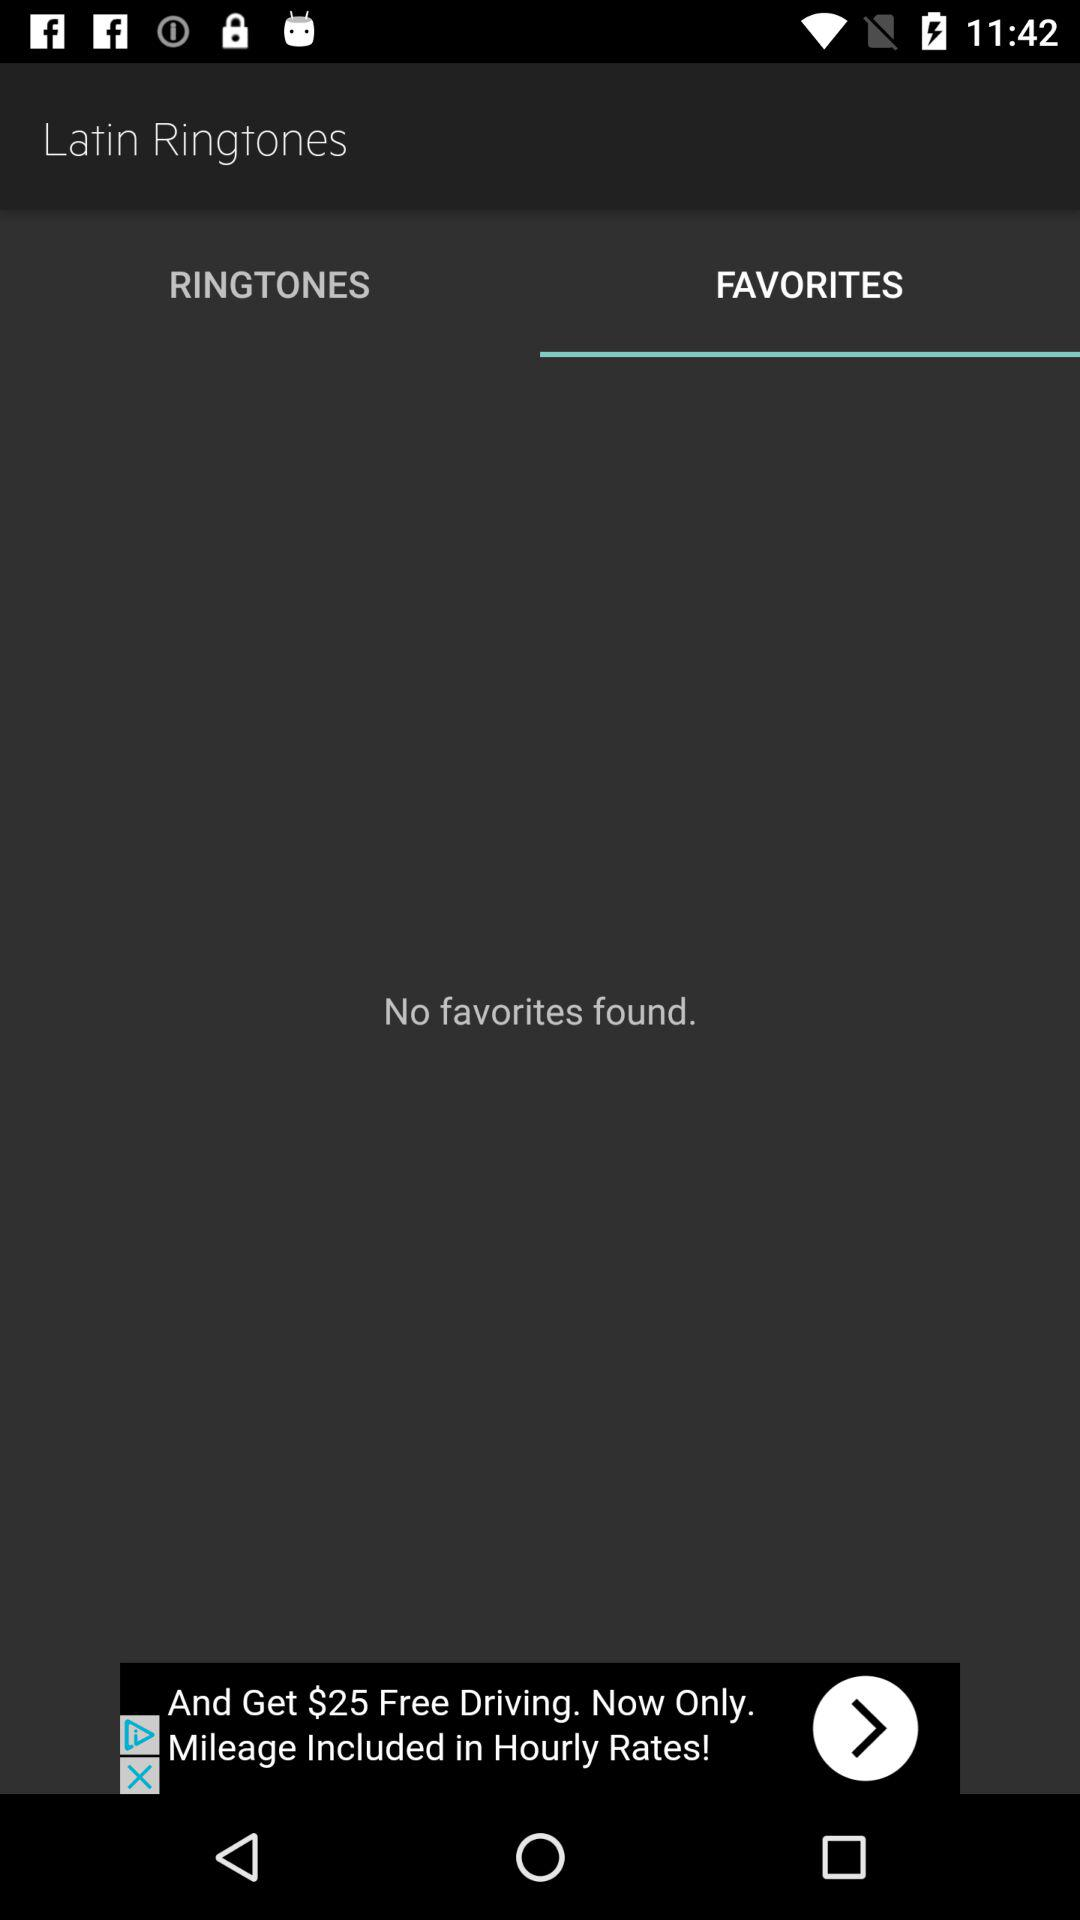Are there any favorites? There are no favorites. 